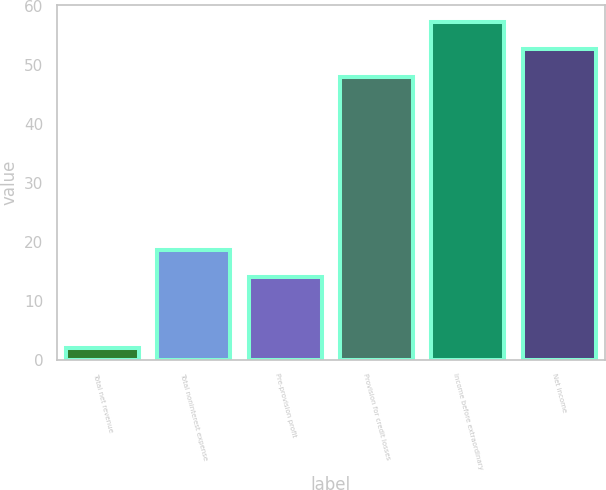<chart> <loc_0><loc_0><loc_500><loc_500><bar_chart><fcel>Total net revenue<fcel>Total noninterest expense<fcel>Pre-provision profit<fcel>Provision for credit losses<fcel>Income before extraordinary<fcel>Net income<nl><fcel>2<fcel>18.7<fcel>14<fcel>48<fcel>57.4<fcel>52.7<nl></chart> 